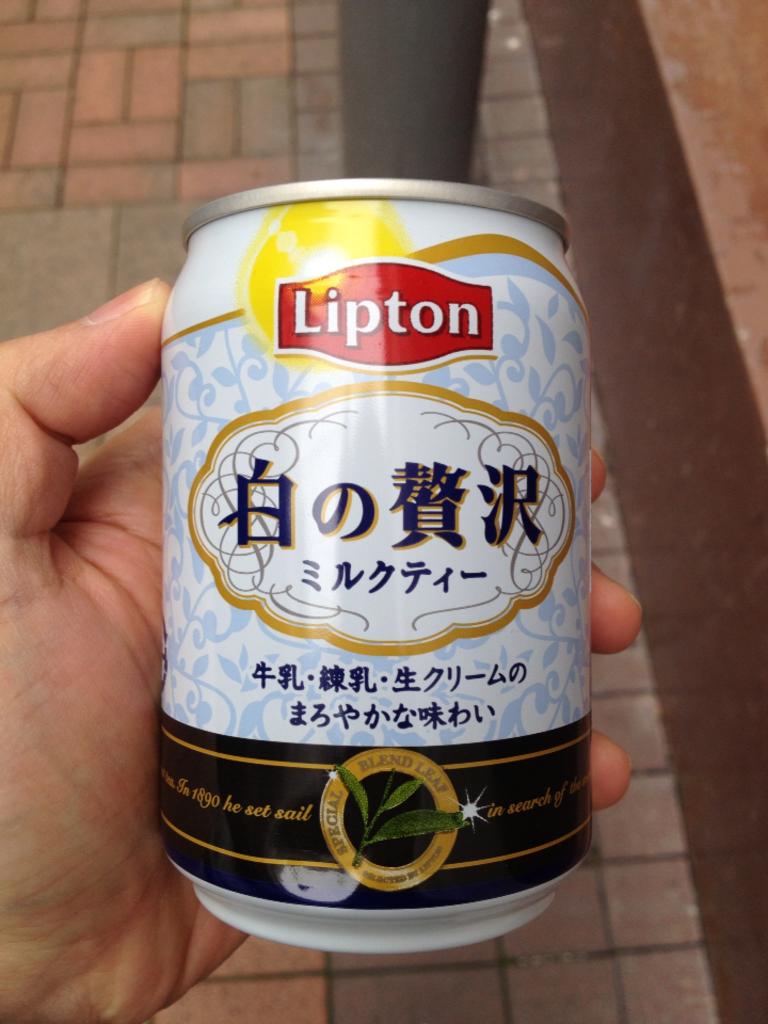What brand is this drink?
Your answer should be compact. Lipton. Is this a can of lipton tea?
Provide a succinct answer. Yes. 